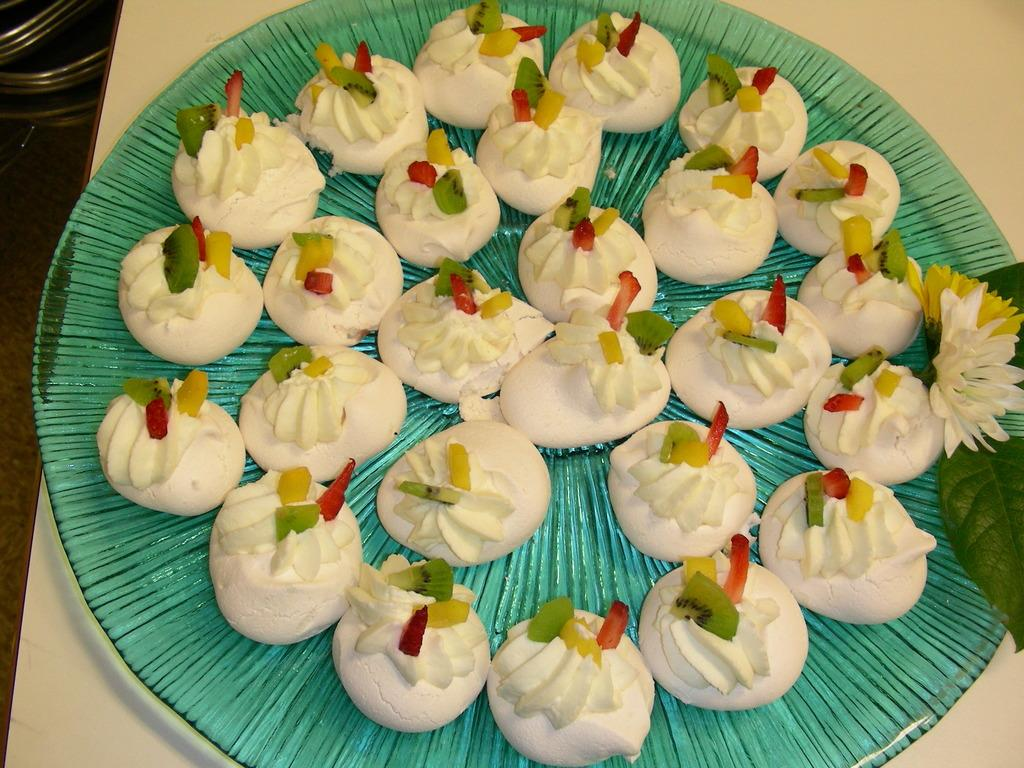What is on the plate that is visible in the image? There is food on a plate in the image. Where is the plate located in the image? The plate is in the center of the image. What nation is represented by the zebra in the image? There is no zebra present in the image, so it is not possible to determine which nation it might represent. 